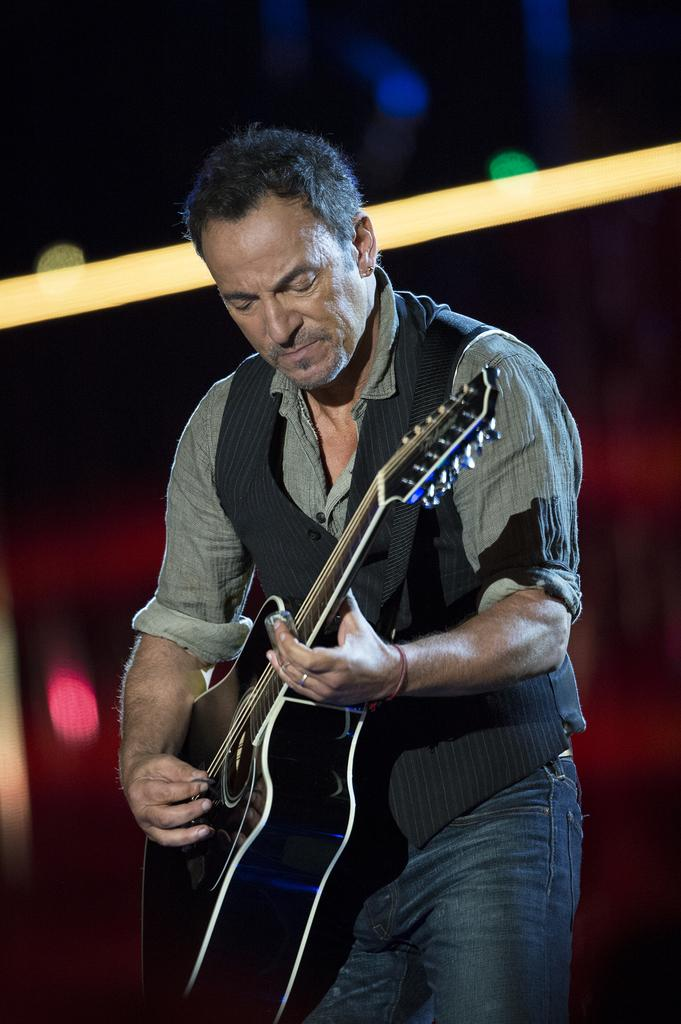Who is in the image? There is a man in the image. What is the man doing in the image? The man is standing and playing the guitar. What is the man wearing in the image? The man is wearing a shirt. What object is the man holding in the image? The man is holding a guitar. What direction is the man facing in the image? The facts provided do not specify the direction the man is facing. However, we can say that the man is not facing north, as there is no mention of a specific direction in the facts. 